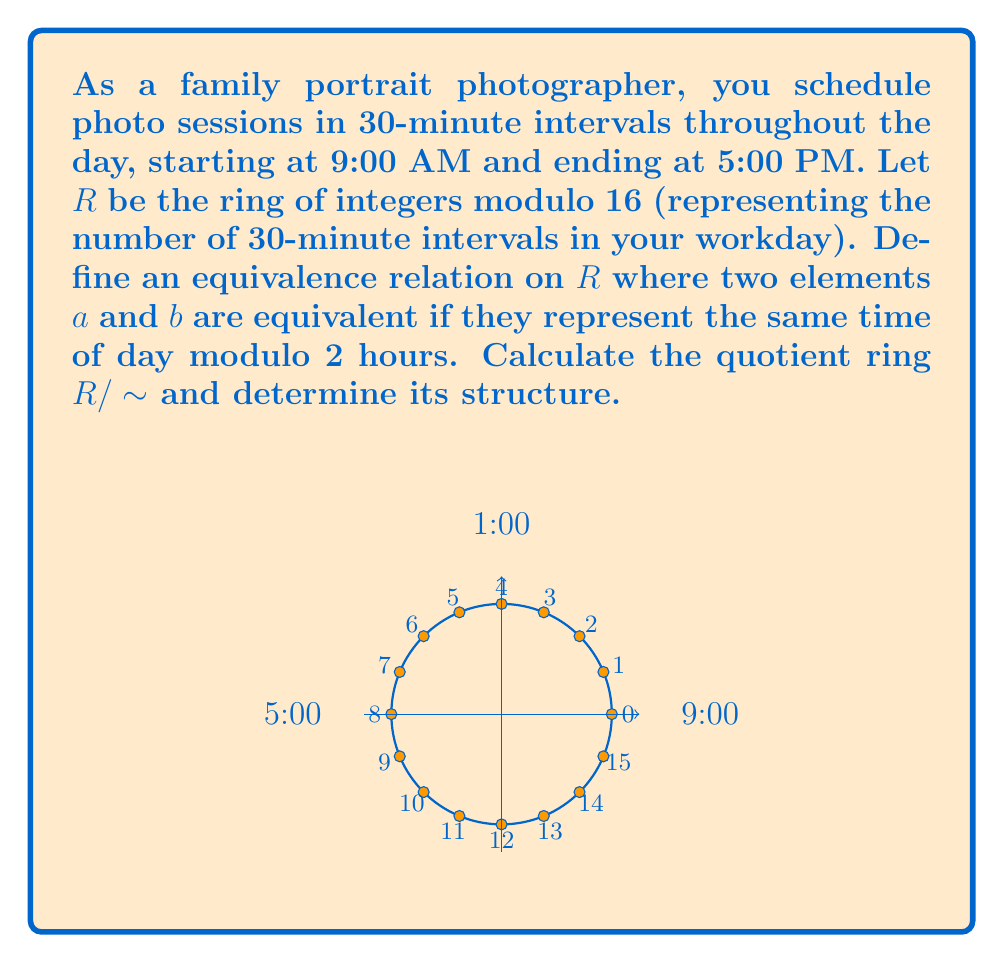Can you answer this question? Let's approach this step-by-step:

1) First, we need to understand what the equivalence relation means:
   Two elements $a$ and $b$ in $R$ are equivalent if they represent the same time of day modulo 2 hours.
   In our ring $R$, 2 hours is represented by 4 elements (since each element represents 30 minutes).

2) This means that $a \sim b$ if and only if $a \equiv b \pmod{4}$ in $R$.

3) The equivalence classes will be:
   $[0] = \{0, 4, 8, 12\}$
   $[1] = \{1, 5, 9, 13\}$
   $[2] = \{2, 6, 10, 14\}$
   $[3] = \{3, 7, 11, 15\}$

4) The quotient ring $R/\sim$ will have these 4 equivalence classes as its elements.

5) To determine the structure of $R/\sim$, we need to look at its order and operations:
   - It has 4 elements
   - Addition and multiplication are inherited from $R$ but performed on representatives of the equivalence classes

6) The addition table for $R/\sim$ would be:
   $$\begin{array}{c|cccc}
   + & [0] & [1] & [2] & [3] \\
   \hline
   [0] & [0] & [1] & [2] & [3] \\
   [1] & [1] & [2] & [3] & [0] \\
   [2] & [2] & [3] & [0] & [1] \\
   [3] & [3] & [0] & [1] & [2]
   \end{array}$$

7) The multiplication table for $R/\sim$ would be:
   $$\begin{array}{c|cccc}
   \times & [0] & [1] & [2] & [3] \\
   \hline
   [0] & [0] & [0] & [0] & [0] \\
   [1] & [0] & [1] & [2] & [3] \\
   [2] & [0] & [2] & [0] & [2] \\
   [3] & [0] & [3] & [2] & [1]
   \end{array}$$

8) This structure is isomorphic to the ring $\mathbb{Z}_4$, the integers modulo 4.
Answer: $R/\sim \cong \mathbb{Z}_4$ 